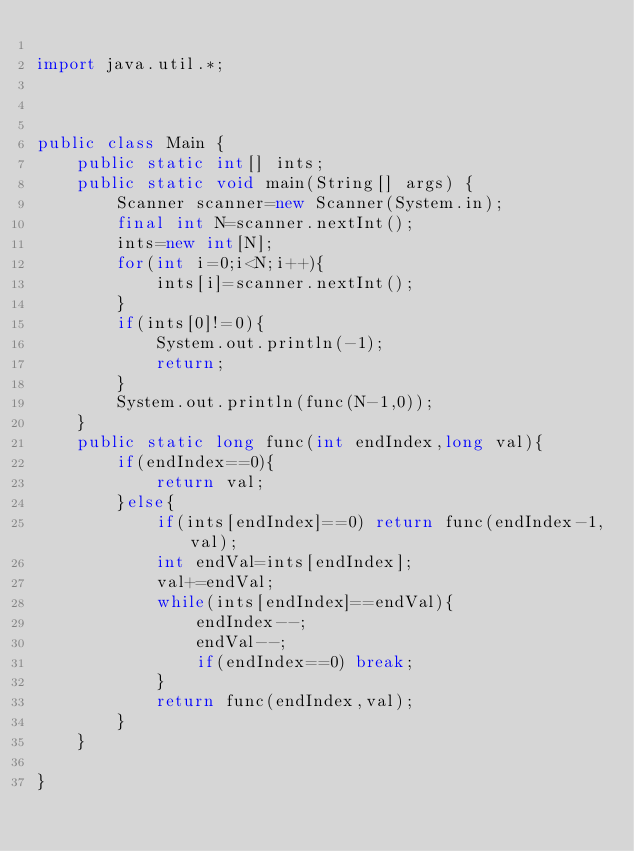Convert code to text. <code><loc_0><loc_0><loc_500><loc_500><_Java_>
import java.util.*;



public class Main {
    public static int[] ints;
    public static void main(String[] args) {
        Scanner scanner=new Scanner(System.in);
        final int N=scanner.nextInt();
        ints=new int[N];
        for(int i=0;i<N;i++){
            ints[i]=scanner.nextInt();
        }
        if(ints[0]!=0){
            System.out.println(-1);
            return;
        }
        System.out.println(func(N-1,0));
    }
    public static long func(int endIndex,long val){
        if(endIndex==0){
            return val;
        }else{
            if(ints[endIndex]==0) return func(endIndex-1,val);
            int endVal=ints[endIndex];
            val+=endVal;
            while(ints[endIndex]==endVal){
                endIndex--;
                endVal--;
                if(endIndex==0) break;
            }
            return func(endIndex,val);
        }
    }

}</code> 